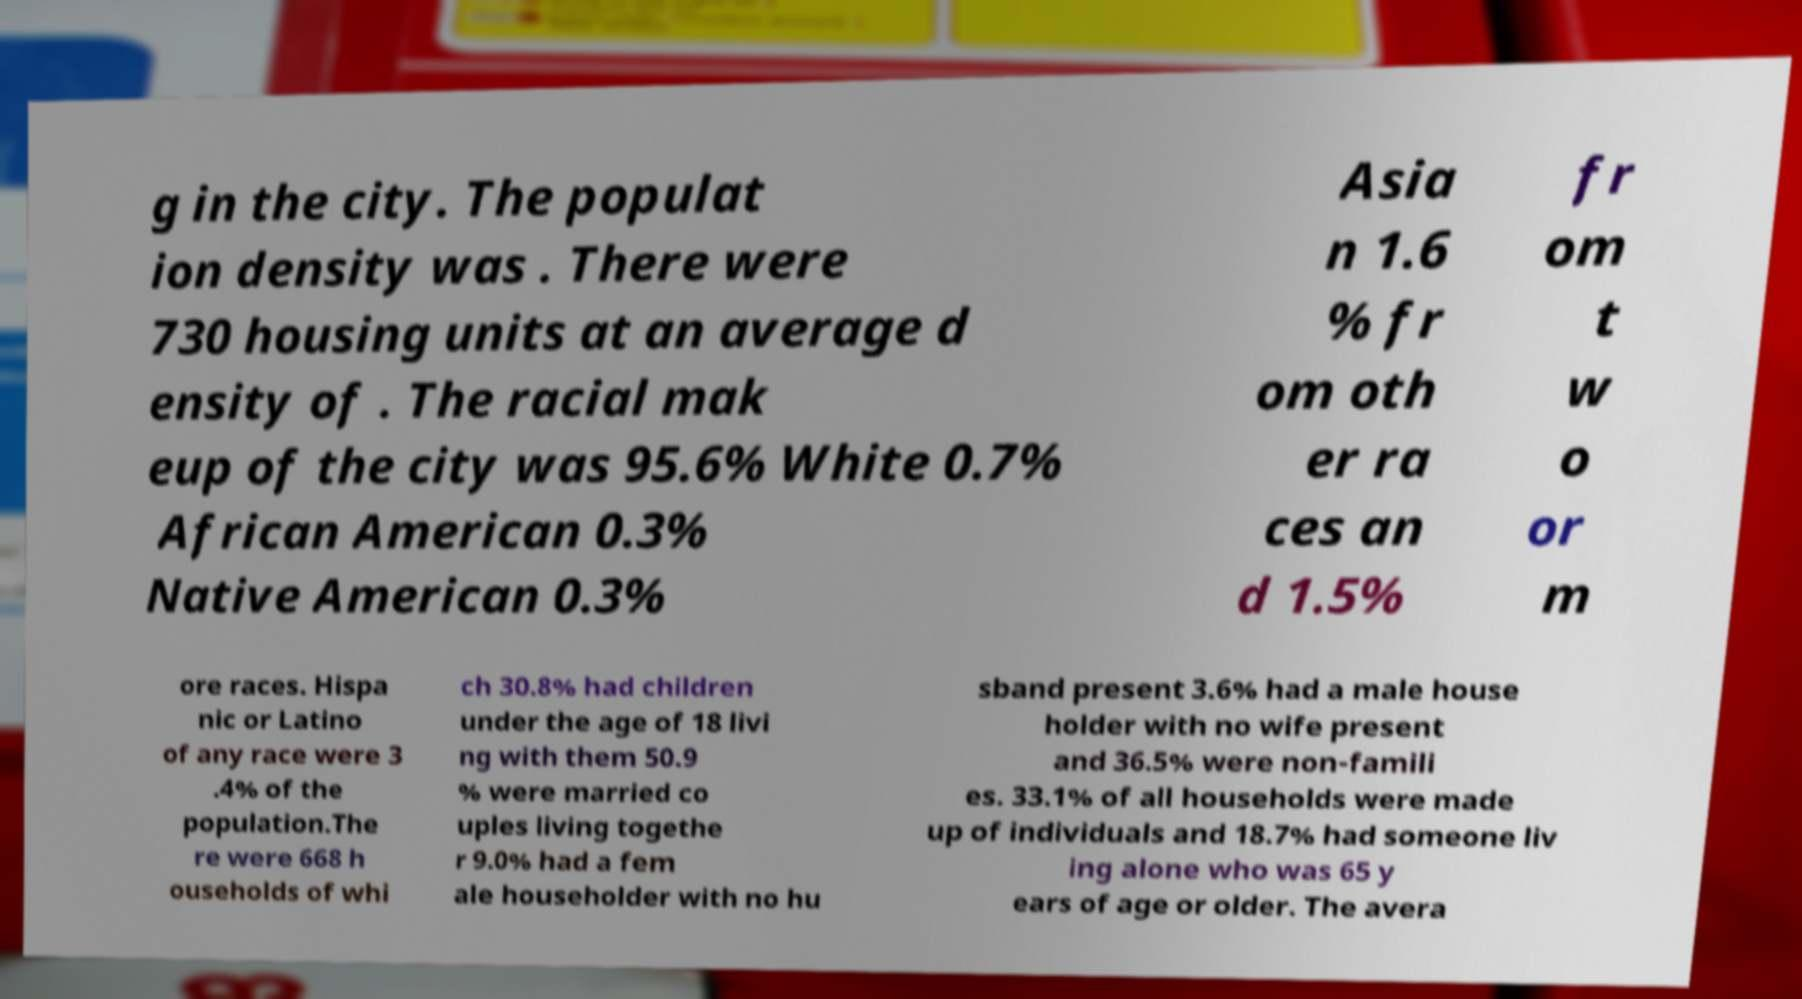Can you read and provide the text displayed in the image?This photo seems to have some interesting text. Can you extract and type it out for me? g in the city. The populat ion density was . There were 730 housing units at an average d ensity of . The racial mak eup of the city was 95.6% White 0.7% African American 0.3% Native American 0.3% Asia n 1.6 % fr om oth er ra ces an d 1.5% fr om t w o or m ore races. Hispa nic or Latino of any race were 3 .4% of the population.The re were 668 h ouseholds of whi ch 30.8% had children under the age of 18 livi ng with them 50.9 % were married co uples living togethe r 9.0% had a fem ale householder with no hu sband present 3.6% had a male house holder with no wife present and 36.5% were non-famili es. 33.1% of all households were made up of individuals and 18.7% had someone liv ing alone who was 65 y ears of age or older. The avera 